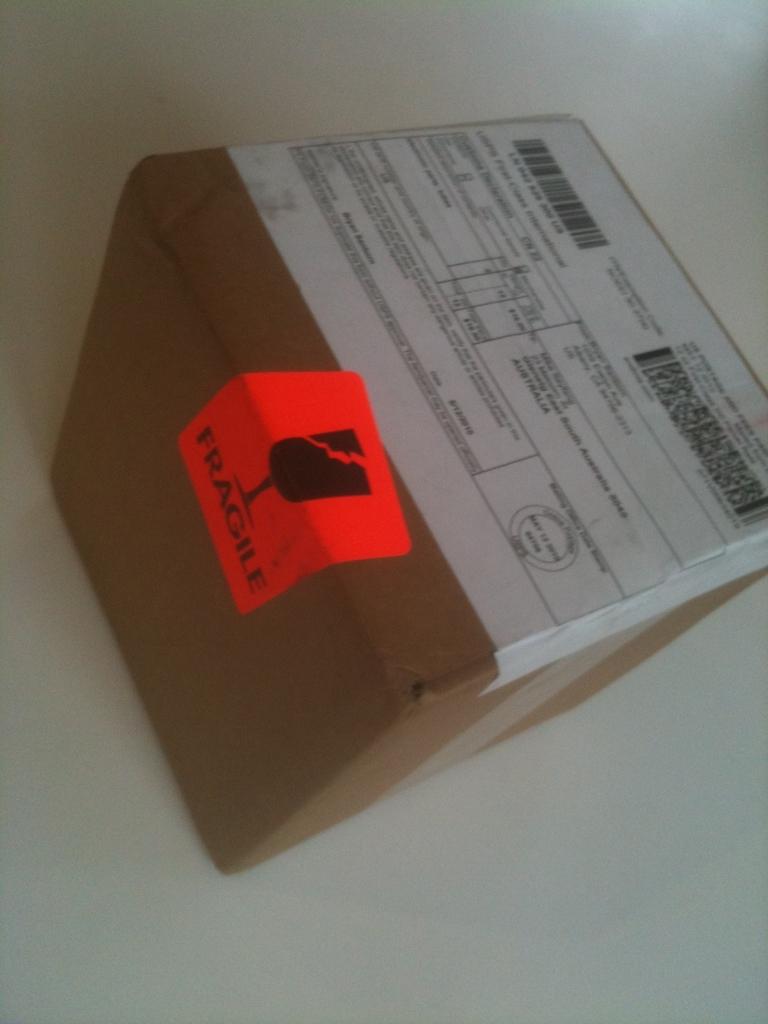Is this package fragile or not?
Make the answer very short. Yes. 